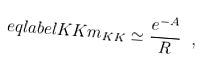<formula> <loc_0><loc_0><loc_500><loc_500>\ e q l a b e l { K K } m _ { K K } \simeq \frac { e ^ { - A } } { R } \ ,</formula> 